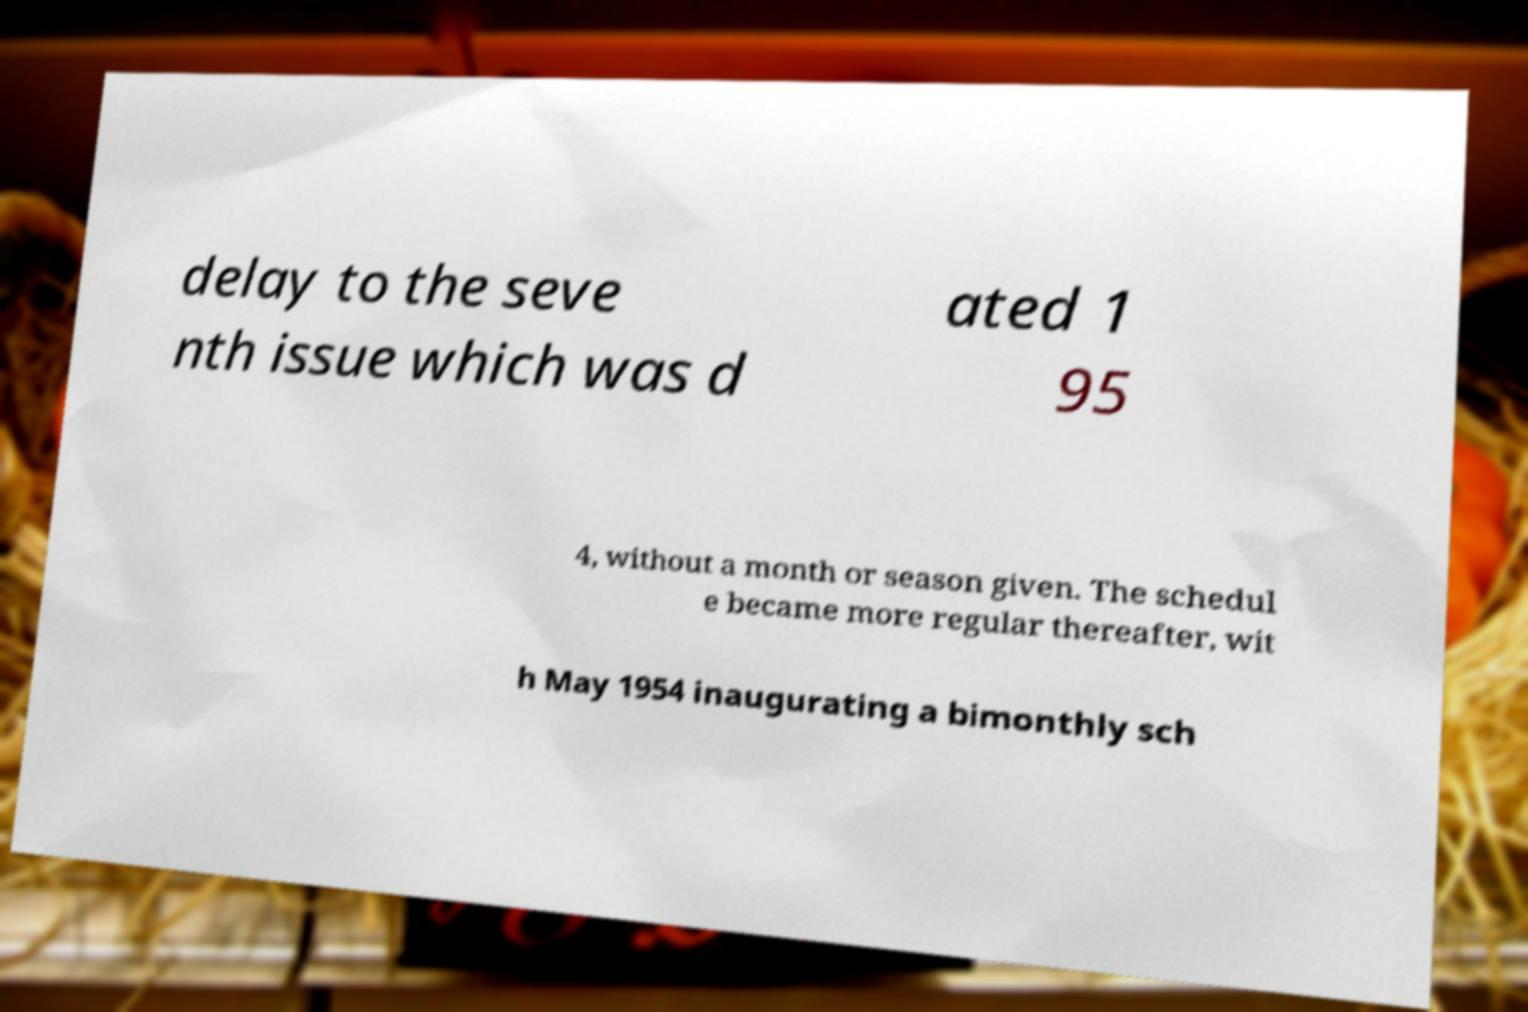For documentation purposes, I need the text within this image transcribed. Could you provide that? delay to the seve nth issue which was d ated 1 95 4, without a month or season given. The schedul e became more regular thereafter, wit h May 1954 inaugurating a bimonthly sch 